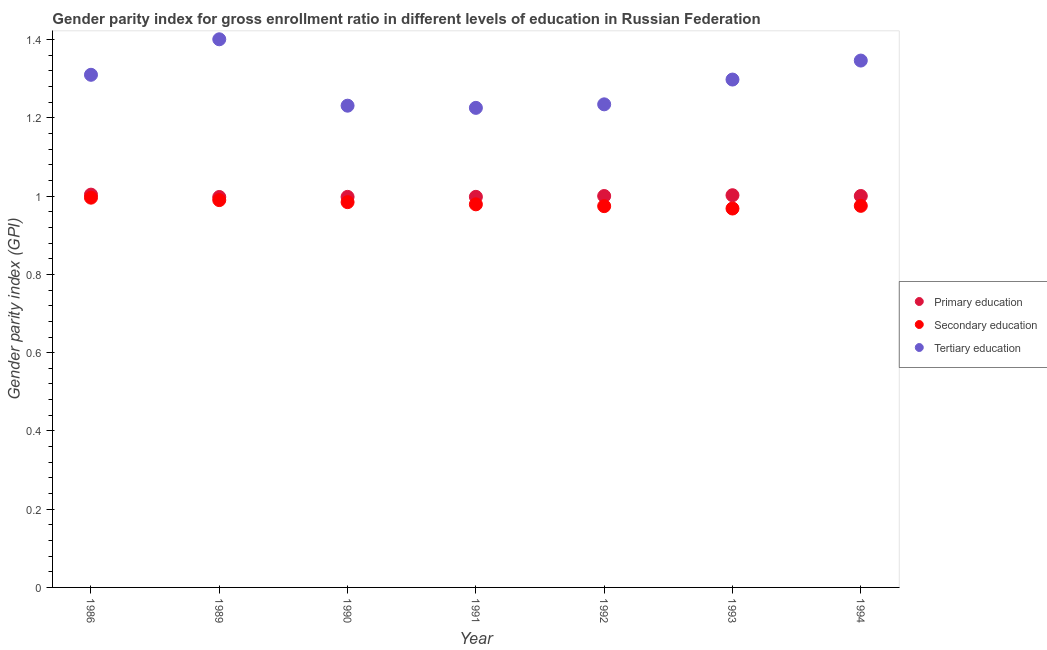Is the number of dotlines equal to the number of legend labels?
Provide a short and direct response. Yes. What is the gender parity index in secondary education in 1989?
Provide a short and direct response. 0.99. Across all years, what is the maximum gender parity index in tertiary education?
Give a very brief answer. 1.4. Across all years, what is the minimum gender parity index in tertiary education?
Ensure brevity in your answer.  1.23. In which year was the gender parity index in secondary education maximum?
Keep it short and to the point. 1986. In which year was the gender parity index in tertiary education minimum?
Your answer should be compact. 1991. What is the total gender parity index in secondary education in the graph?
Keep it short and to the point. 6.87. What is the difference between the gender parity index in tertiary education in 1989 and that in 1994?
Give a very brief answer. 0.05. What is the difference between the gender parity index in primary education in 1994 and the gender parity index in tertiary education in 1986?
Your answer should be compact. -0.31. What is the average gender parity index in tertiary education per year?
Keep it short and to the point. 1.29. In the year 1986, what is the difference between the gender parity index in primary education and gender parity index in secondary education?
Make the answer very short. 0.01. What is the ratio of the gender parity index in tertiary education in 1990 to that in 1993?
Make the answer very short. 0.95. Is the gender parity index in secondary education in 1986 less than that in 1989?
Offer a very short reply. No. What is the difference between the highest and the second highest gender parity index in secondary education?
Provide a short and direct response. 0.01. What is the difference between the highest and the lowest gender parity index in secondary education?
Provide a succinct answer. 0.03. Is it the case that in every year, the sum of the gender parity index in primary education and gender parity index in secondary education is greater than the gender parity index in tertiary education?
Give a very brief answer. Yes. Does the gender parity index in primary education monotonically increase over the years?
Keep it short and to the point. No. How many dotlines are there?
Offer a very short reply. 3. How many years are there in the graph?
Give a very brief answer. 7. Are the values on the major ticks of Y-axis written in scientific E-notation?
Your answer should be compact. No. Where does the legend appear in the graph?
Your answer should be very brief. Center right. How are the legend labels stacked?
Keep it short and to the point. Vertical. What is the title of the graph?
Give a very brief answer. Gender parity index for gross enrollment ratio in different levels of education in Russian Federation. What is the label or title of the Y-axis?
Provide a succinct answer. Gender parity index (GPI). What is the Gender parity index (GPI) in Primary education in 1986?
Your response must be concise. 1. What is the Gender parity index (GPI) in Secondary education in 1986?
Your answer should be very brief. 1. What is the Gender parity index (GPI) in Tertiary education in 1986?
Give a very brief answer. 1.31. What is the Gender parity index (GPI) of Primary education in 1989?
Ensure brevity in your answer.  1. What is the Gender parity index (GPI) in Secondary education in 1989?
Give a very brief answer. 0.99. What is the Gender parity index (GPI) in Tertiary education in 1989?
Provide a short and direct response. 1.4. What is the Gender parity index (GPI) of Primary education in 1990?
Your answer should be very brief. 1. What is the Gender parity index (GPI) of Secondary education in 1990?
Offer a very short reply. 0.98. What is the Gender parity index (GPI) of Tertiary education in 1990?
Keep it short and to the point. 1.23. What is the Gender parity index (GPI) of Primary education in 1991?
Give a very brief answer. 1. What is the Gender parity index (GPI) of Secondary education in 1991?
Your response must be concise. 0.98. What is the Gender parity index (GPI) in Tertiary education in 1991?
Ensure brevity in your answer.  1.23. What is the Gender parity index (GPI) in Primary education in 1992?
Ensure brevity in your answer.  1. What is the Gender parity index (GPI) of Secondary education in 1992?
Your answer should be compact. 0.97. What is the Gender parity index (GPI) of Tertiary education in 1992?
Your response must be concise. 1.23. What is the Gender parity index (GPI) in Primary education in 1993?
Give a very brief answer. 1. What is the Gender parity index (GPI) in Secondary education in 1993?
Provide a short and direct response. 0.97. What is the Gender parity index (GPI) of Tertiary education in 1993?
Provide a succinct answer. 1.3. What is the Gender parity index (GPI) of Primary education in 1994?
Give a very brief answer. 1. What is the Gender parity index (GPI) in Secondary education in 1994?
Offer a very short reply. 0.98. What is the Gender parity index (GPI) of Tertiary education in 1994?
Provide a short and direct response. 1.35. Across all years, what is the maximum Gender parity index (GPI) in Primary education?
Keep it short and to the point. 1. Across all years, what is the maximum Gender parity index (GPI) of Secondary education?
Ensure brevity in your answer.  1. Across all years, what is the maximum Gender parity index (GPI) of Tertiary education?
Keep it short and to the point. 1.4. Across all years, what is the minimum Gender parity index (GPI) in Primary education?
Make the answer very short. 1. Across all years, what is the minimum Gender parity index (GPI) in Secondary education?
Ensure brevity in your answer.  0.97. Across all years, what is the minimum Gender parity index (GPI) of Tertiary education?
Offer a very short reply. 1.23. What is the total Gender parity index (GPI) in Primary education in the graph?
Offer a very short reply. 7. What is the total Gender parity index (GPI) in Secondary education in the graph?
Your answer should be compact. 6.87. What is the total Gender parity index (GPI) of Tertiary education in the graph?
Give a very brief answer. 9.05. What is the difference between the Gender parity index (GPI) in Primary education in 1986 and that in 1989?
Ensure brevity in your answer.  0.01. What is the difference between the Gender parity index (GPI) of Secondary education in 1986 and that in 1989?
Your response must be concise. 0.01. What is the difference between the Gender parity index (GPI) of Tertiary education in 1986 and that in 1989?
Provide a short and direct response. -0.09. What is the difference between the Gender parity index (GPI) of Primary education in 1986 and that in 1990?
Offer a terse response. 0.01. What is the difference between the Gender parity index (GPI) of Secondary education in 1986 and that in 1990?
Your answer should be compact. 0.01. What is the difference between the Gender parity index (GPI) in Tertiary education in 1986 and that in 1990?
Provide a succinct answer. 0.08. What is the difference between the Gender parity index (GPI) in Primary education in 1986 and that in 1991?
Ensure brevity in your answer.  0.01. What is the difference between the Gender parity index (GPI) in Secondary education in 1986 and that in 1991?
Your answer should be very brief. 0.02. What is the difference between the Gender parity index (GPI) in Tertiary education in 1986 and that in 1991?
Give a very brief answer. 0.08. What is the difference between the Gender parity index (GPI) of Primary education in 1986 and that in 1992?
Offer a terse response. 0. What is the difference between the Gender parity index (GPI) of Secondary education in 1986 and that in 1992?
Make the answer very short. 0.02. What is the difference between the Gender parity index (GPI) in Tertiary education in 1986 and that in 1992?
Give a very brief answer. 0.08. What is the difference between the Gender parity index (GPI) of Primary education in 1986 and that in 1993?
Make the answer very short. 0. What is the difference between the Gender parity index (GPI) of Secondary education in 1986 and that in 1993?
Provide a short and direct response. 0.03. What is the difference between the Gender parity index (GPI) in Tertiary education in 1986 and that in 1993?
Give a very brief answer. 0.01. What is the difference between the Gender parity index (GPI) in Primary education in 1986 and that in 1994?
Offer a terse response. 0. What is the difference between the Gender parity index (GPI) in Secondary education in 1986 and that in 1994?
Keep it short and to the point. 0.02. What is the difference between the Gender parity index (GPI) in Tertiary education in 1986 and that in 1994?
Your response must be concise. -0.04. What is the difference between the Gender parity index (GPI) in Primary education in 1989 and that in 1990?
Offer a terse response. -0. What is the difference between the Gender parity index (GPI) in Secondary education in 1989 and that in 1990?
Make the answer very short. 0.01. What is the difference between the Gender parity index (GPI) in Tertiary education in 1989 and that in 1990?
Provide a short and direct response. 0.17. What is the difference between the Gender parity index (GPI) in Primary education in 1989 and that in 1991?
Provide a short and direct response. -0. What is the difference between the Gender parity index (GPI) in Secondary education in 1989 and that in 1991?
Provide a succinct answer. 0.01. What is the difference between the Gender parity index (GPI) of Tertiary education in 1989 and that in 1991?
Your answer should be very brief. 0.18. What is the difference between the Gender parity index (GPI) in Primary education in 1989 and that in 1992?
Provide a succinct answer. -0. What is the difference between the Gender parity index (GPI) of Secondary education in 1989 and that in 1992?
Make the answer very short. 0.02. What is the difference between the Gender parity index (GPI) in Tertiary education in 1989 and that in 1992?
Provide a short and direct response. 0.17. What is the difference between the Gender parity index (GPI) in Primary education in 1989 and that in 1993?
Offer a very short reply. -0. What is the difference between the Gender parity index (GPI) of Secondary education in 1989 and that in 1993?
Your answer should be very brief. 0.02. What is the difference between the Gender parity index (GPI) of Tertiary education in 1989 and that in 1993?
Provide a succinct answer. 0.1. What is the difference between the Gender parity index (GPI) of Primary education in 1989 and that in 1994?
Offer a terse response. -0. What is the difference between the Gender parity index (GPI) in Secondary education in 1989 and that in 1994?
Ensure brevity in your answer.  0.01. What is the difference between the Gender parity index (GPI) in Tertiary education in 1989 and that in 1994?
Offer a very short reply. 0.05. What is the difference between the Gender parity index (GPI) of Primary education in 1990 and that in 1991?
Your answer should be very brief. -0. What is the difference between the Gender parity index (GPI) in Secondary education in 1990 and that in 1991?
Keep it short and to the point. 0.01. What is the difference between the Gender parity index (GPI) of Tertiary education in 1990 and that in 1991?
Your response must be concise. 0.01. What is the difference between the Gender parity index (GPI) in Primary education in 1990 and that in 1992?
Give a very brief answer. -0. What is the difference between the Gender parity index (GPI) in Secondary education in 1990 and that in 1992?
Offer a very short reply. 0.01. What is the difference between the Gender parity index (GPI) in Tertiary education in 1990 and that in 1992?
Offer a terse response. -0. What is the difference between the Gender parity index (GPI) of Primary education in 1990 and that in 1993?
Keep it short and to the point. -0. What is the difference between the Gender parity index (GPI) of Secondary education in 1990 and that in 1993?
Your answer should be compact. 0.02. What is the difference between the Gender parity index (GPI) in Tertiary education in 1990 and that in 1993?
Give a very brief answer. -0.07. What is the difference between the Gender parity index (GPI) of Primary education in 1990 and that in 1994?
Keep it short and to the point. -0. What is the difference between the Gender parity index (GPI) in Secondary education in 1990 and that in 1994?
Offer a terse response. 0.01. What is the difference between the Gender parity index (GPI) of Tertiary education in 1990 and that in 1994?
Give a very brief answer. -0.12. What is the difference between the Gender parity index (GPI) of Primary education in 1991 and that in 1992?
Your answer should be compact. -0. What is the difference between the Gender parity index (GPI) in Secondary education in 1991 and that in 1992?
Your response must be concise. 0. What is the difference between the Gender parity index (GPI) in Tertiary education in 1991 and that in 1992?
Ensure brevity in your answer.  -0.01. What is the difference between the Gender parity index (GPI) of Primary education in 1991 and that in 1993?
Give a very brief answer. -0. What is the difference between the Gender parity index (GPI) in Secondary education in 1991 and that in 1993?
Give a very brief answer. 0.01. What is the difference between the Gender parity index (GPI) in Tertiary education in 1991 and that in 1993?
Offer a terse response. -0.07. What is the difference between the Gender parity index (GPI) in Primary education in 1991 and that in 1994?
Provide a short and direct response. -0. What is the difference between the Gender parity index (GPI) of Secondary education in 1991 and that in 1994?
Keep it short and to the point. 0. What is the difference between the Gender parity index (GPI) of Tertiary education in 1991 and that in 1994?
Offer a very short reply. -0.12. What is the difference between the Gender parity index (GPI) in Primary education in 1992 and that in 1993?
Provide a short and direct response. -0. What is the difference between the Gender parity index (GPI) in Secondary education in 1992 and that in 1993?
Provide a short and direct response. 0.01. What is the difference between the Gender parity index (GPI) of Tertiary education in 1992 and that in 1993?
Your answer should be compact. -0.06. What is the difference between the Gender parity index (GPI) of Primary education in 1992 and that in 1994?
Give a very brief answer. -0. What is the difference between the Gender parity index (GPI) in Secondary education in 1992 and that in 1994?
Your response must be concise. -0. What is the difference between the Gender parity index (GPI) in Tertiary education in 1992 and that in 1994?
Offer a very short reply. -0.11. What is the difference between the Gender parity index (GPI) of Primary education in 1993 and that in 1994?
Ensure brevity in your answer.  0. What is the difference between the Gender parity index (GPI) in Secondary education in 1993 and that in 1994?
Your answer should be compact. -0.01. What is the difference between the Gender parity index (GPI) of Tertiary education in 1993 and that in 1994?
Offer a terse response. -0.05. What is the difference between the Gender parity index (GPI) of Primary education in 1986 and the Gender parity index (GPI) of Secondary education in 1989?
Provide a succinct answer. 0.01. What is the difference between the Gender parity index (GPI) in Primary education in 1986 and the Gender parity index (GPI) in Tertiary education in 1989?
Offer a terse response. -0.4. What is the difference between the Gender parity index (GPI) in Secondary education in 1986 and the Gender parity index (GPI) in Tertiary education in 1989?
Offer a terse response. -0.4. What is the difference between the Gender parity index (GPI) in Primary education in 1986 and the Gender parity index (GPI) in Secondary education in 1990?
Your response must be concise. 0.02. What is the difference between the Gender parity index (GPI) of Primary education in 1986 and the Gender parity index (GPI) of Tertiary education in 1990?
Offer a terse response. -0.23. What is the difference between the Gender parity index (GPI) of Secondary education in 1986 and the Gender parity index (GPI) of Tertiary education in 1990?
Provide a succinct answer. -0.24. What is the difference between the Gender parity index (GPI) in Primary education in 1986 and the Gender parity index (GPI) in Secondary education in 1991?
Your answer should be compact. 0.02. What is the difference between the Gender parity index (GPI) in Primary education in 1986 and the Gender parity index (GPI) in Tertiary education in 1991?
Ensure brevity in your answer.  -0.22. What is the difference between the Gender parity index (GPI) in Secondary education in 1986 and the Gender parity index (GPI) in Tertiary education in 1991?
Your answer should be compact. -0.23. What is the difference between the Gender parity index (GPI) of Primary education in 1986 and the Gender parity index (GPI) of Secondary education in 1992?
Ensure brevity in your answer.  0.03. What is the difference between the Gender parity index (GPI) of Primary education in 1986 and the Gender parity index (GPI) of Tertiary education in 1992?
Make the answer very short. -0.23. What is the difference between the Gender parity index (GPI) of Secondary education in 1986 and the Gender parity index (GPI) of Tertiary education in 1992?
Your answer should be very brief. -0.24. What is the difference between the Gender parity index (GPI) in Primary education in 1986 and the Gender parity index (GPI) in Secondary education in 1993?
Provide a short and direct response. 0.04. What is the difference between the Gender parity index (GPI) of Primary education in 1986 and the Gender parity index (GPI) of Tertiary education in 1993?
Provide a short and direct response. -0.29. What is the difference between the Gender parity index (GPI) in Secondary education in 1986 and the Gender parity index (GPI) in Tertiary education in 1993?
Keep it short and to the point. -0.3. What is the difference between the Gender parity index (GPI) in Primary education in 1986 and the Gender parity index (GPI) in Secondary education in 1994?
Your answer should be compact. 0.03. What is the difference between the Gender parity index (GPI) in Primary education in 1986 and the Gender parity index (GPI) in Tertiary education in 1994?
Keep it short and to the point. -0.34. What is the difference between the Gender parity index (GPI) of Secondary education in 1986 and the Gender parity index (GPI) of Tertiary education in 1994?
Your response must be concise. -0.35. What is the difference between the Gender parity index (GPI) of Primary education in 1989 and the Gender parity index (GPI) of Secondary education in 1990?
Offer a terse response. 0.01. What is the difference between the Gender parity index (GPI) of Primary education in 1989 and the Gender parity index (GPI) of Tertiary education in 1990?
Provide a short and direct response. -0.23. What is the difference between the Gender parity index (GPI) in Secondary education in 1989 and the Gender parity index (GPI) in Tertiary education in 1990?
Ensure brevity in your answer.  -0.24. What is the difference between the Gender parity index (GPI) of Primary education in 1989 and the Gender parity index (GPI) of Secondary education in 1991?
Ensure brevity in your answer.  0.02. What is the difference between the Gender parity index (GPI) of Primary education in 1989 and the Gender parity index (GPI) of Tertiary education in 1991?
Provide a succinct answer. -0.23. What is the difference between the Gender parity index (GPI) of Secondary education in 1989 and the Gender parity index (GPI) of Tertiary education in 1991?
Keep it short and to the point. -0.24. What is the difference between the Gender parity index (GPI) of Primary education in 1989 and the Gender parity index (GPI) of Secondary education in 1992?
Your response must be concise. 0.02. What is the difference between the Gender parity index (GPI) in Primary education in 1989 and the Gender parity index (GPI) in Tertiary education in 1992?
Keep it short and to the point. -0.24. What is the difference between the Gender parity index (GPI) of Secondary education in 1989 and the Gender parity index (GPI) of Tertiary education in 1992?
Offer a terse response. -0.24. What is the difference between the Gender parity index (GPI) of Primary education in 1989 and the Gender parity index (GPI) of Secondary education in 1993?
Keep it short and to the point. 0.03. What is the difference between the Gender parity index (GPI) of Primary education in 1989 and the Gender parity index (GPI) of Tertiary education in 1993?
Make the answer very short. -0.3. What is the difference between the Gender parity index (GPI) in Secondary education in 1989 and the Gender parity index (GPI) in Tertiary education in 1993?
Your answer should be compact. -0.31. What is the difference between the Gender parity index (GPI) of Primary education in 1989 and the Gender parity index (GPI) of Secondary education in 1994?
Your response must be concise. 0.02. What is the difference between the Gender parity index (GPI) of Primary education in 1989 and the Gender parity index (GPI) of Tertiary education in 1994?
Keep it short and to the point. -0.35. What is the difference between the Gender parity index (GPI) of Secondary education in 1989 and the Gender parity index (GPI) of Tertiary education in 1994?
Your response must be concise. -0.36. What is the difference between the Gender parity index (GPI) in Primary education in 1990 and the Gender parity index (GPI) in Secondary education in 1991?
Provide a short and direct response. 0.02. What is the difference between the Gender parity index (GPI) in Primary education in 1990 and the Gender parity index (GPI) in Tertiary education in 1991?
Ensure brevity in your answer.  -0.23. What is the difference between the Gender parity index (GPI) of Secondary education in 1990 and the Gender parity index (GPI) of Tertiary education in 1991?
Provide a succinct answer. -0.24. What is the difference between the Gender parity index (GPI) of Primary education in 1990 and the Gender parity index (GPI) of Secondary education in 1992?
Ensure brevity in your answer.  0.02. What is the difference between the Gender parity index (GPI) in Primary education in 1990 and the Gender parity index (GPI) in Tertiary education in 1992?
Provide a short and direct response. -0.24. What is the difference between the Gender parity index (GPI) of Primary education in 1990 and the Gender parity index (GPI) of Secondary education in 1993?
Keep it short and to the point. 0.03. What is the difference between the Gender parity index (GPI) of Primary education in 1990 and the Gender parity index (GPI) of Tertiary education in 1993?
Provide a short and direct response. -0.3. What is the difference between the Gender parity index (GPI) in Secondary education in 1990 and the Gender parity index (GPI) in Tertiary education in 1993?
Your response must be concise. -0.31. What is the difference between the Gender parity index (GPI) in Primary education in 1990 and the Gender parity index (GPI) in Secondary education in 1994?
Your response must be concise. 0.02. What is the difference between the Gender parity index (GPI) of Primary education in 1990 and the Gender parity index (GPI) of Tertiary education in 1994?
Your answer should be compact. -0.35. What is the difference between the Gender parity index (GPI) of Secondary education in 1990 and the Gender parity index (GPI) of Tertiary education in 1994?
Give a very brief answer. -0.36. What is the difference between the Gender parity index (GPI) in Primary education in 1991 and the Gender parity index (GPI) in Secondary education in 1992?
Ensure brevity in your answer.  0.02. What is the difference between the Gender parity index (GPI) in Primary education in 1991 and the Gender parity index (GPI) in Tertiary education in 1992?
Make the answer very short. -0.24. What is the difference between the Gender parity index (GPI) in Secondary education in 1991 and the Gender parity index (GPI) in Tertiary education in 1992?
Give a very brief answer. -0.26. What is the difference between the Gender parity index (GPI) of Primary education in 1991 and the Gender parity index (GPI) of Secondary education in 1993?
Give a very brief answer. 0.03. What is the difference between the Gender parity index (GPI) in Primary education in 1991 and the Gender parity index (GPI) in Tertiary education in 1993?
Provide a succinct answer. -0.3. What is the difference between the Gender parity index (GPI) in Secondary education in 1991 and the Gender parity index (GPI) in Tertiary education in 1993?
Offer a very short reply. -0.32. What is the difference between the Gender parity index (GPI) in Primary education in 1991 and the Gender parity index (GPI) in Secondary education in 1994?
Offer a very short reply. 0.02. What is the difference between the Gender parity index (GPI) of Primary education in 1991 and the Gender parity index (GPI) of Tertiary education in 1994?
Make the answer very short. -0.35. What is the difference between the Gender parity index (GPI) of Secondary education in 1991 and the Gender parity index (GPI) of Tertiary education in 1994?
Offer a very short reply. -0.37. What is the difference between the Gender parity index (GPI) of Primary education in 1992 and the Gender parity index (GPI) of Secondary education in 1993?
Give a very brief answer. 0.03. What is the difference between the Gender parity index (GPI) of Primary education in 1992 and the Gender parity index (GPI) of Tertiary education in 1993?
Make the answer very short. -0.3. What is the difference between the Gender parity index (GPI) in Secondary education in 1992 and the Gender parity index (GPI) in Tertiary education in 1993?
Offer a very short reply. -0.32. What is the difference between the Gender parity index (GPI) in Primary education in 1992 and the Gender parity index (GPI) in Secondary education in 1994?
Your answer should be very brief. 0.03. What is the difference between the Gender parity index (GPI) in Primary education in 1992 and the Gender parity index (GPI) in Tertiary education in 1994?
Offer a very short reply. -0.35. What is the difference between the Gender parity index (GPI) in Secondary education in 1992 and the Gender parity index (GPI) in Tertiary education in 1994?
Your response must be concise. -0.37. What is the difference between the Gender parity index (GPI) in Primary education in 1993 and the Gender parity index (GPI) in Secondary education in 1994?
Provide a short and direct response. 0.03. What is the difference between the Gender parity index (GPI) in Primary education in 1993 and the Gender parity index (GPI) in Tertiary education in 1994?
Your answer should be compact. -0.34. What is the difference between the Gender parity index (GPI) in Secondary education in 1993 and the Gender parity index (GPI) in Tertiary education in 1994?
Your answer should be very brief. -0.38. What is the average Gender parity index (GPI) in Primary education per year?
Your response must be concise. 1. What is the average Gender parity index (GPI) in Secondary education per year?
Your answer should be very brief. 0.98. What is the average Gender parity index (GPI) in Tertiary education per year?
Offer a very short reply. 1.29. In the year 1986, what is the difference between the Gender parity index (GPI) in Primary education and Gender parity index (GPI) in Secondary education?
Give a very brief answer. 0.01. In the year 1986, what is the difference between the Gender parity index (GPI) of Primary education and Gender parity index (GPI) of Tertiary education?
Your response must be concise. -0.31. In the year 1986, what is the difference between the Gender parity index (GPI) of Secondary education and Gender parity index (GPI) of Tertiary education?
Ensure brevity in your answer.  -0.31. In the year 1989, what is the difference between the Gender parity index (GPI) of Primary education and Gender parity index (GPI) of Secondary education?
Keep it short and to the point. 0.01. In the year 1989, what is the difference between the Gender parity index (GPI) in Primary education and Gender parity index (GPI) in Tertiary education?
Keep it short and to the point. -0.4. In the year 1989, what is the difference between the Gender parity index (GPI) of Secondary education and Gender parity index (GPI) of Tertiary education?
Provide a short and direct response. -0.41. In the year 1990, what is the difference between the Gender parity index (GPI) of Primary education and Gender parity index (GPI) of Secondary education?
Provide a succinct answer. 0.01. In the year 1990, what is the difference between the Gender parity index (GPI) of Primary education and Gender parity index (GPI) of Tertiary education?
Provide a short and direct response. -0.23. In the year 1990, what is the difference between the Gender parity index (GPI) of Secondary education and Gender parity index (GPI) of Tertiary education?
Your answer should be very brief. -0.25. In the year 1991, what is the difference between the Gender parity index (GPI) of Primary education and Gender parity index (GPI) of Secondary education?
Your answer should be compact. 0.02. In the year 1991, what is the difference between the Gender parity index (GPI) in Primary education and Gender parity index (GPI) in Tertiary education?
Offer a very short reply. -0.23. In the year 1991, what is the difference between the Gender parity index (GPI) in Secondary education and Gender parity index (GPI) in Tertiary education?
Offer a terse response. -0.25. In the year 1992, what is the difference between the Gender parity index (GPI) in Primary education and Gender parity index (GPI) in Secondary education?
Ensure brevity in your answer.  0.03. In the year 1992, what is the difference between the Gender parity index (GPI) of Primary education and Gender parity index (GPI) of Tertiary education?
Your answer should be very brief. -0.23. In the year 1992, what is the difference between the Gender parity index (GPI) in Secondary education and Gender parity index (GPI) in Tertiary education?
Offer a terse response. -0.26. In the year 1993, what is the difference between the Gender parity index (GPI) of Primary education and Gender parity index (GPI) of Secondary education?
Offer a terse response. 0.03. In the year 1993, what is the difference between the Gender parity index (GPI) of Primary education and Gender parity index (GPI) of Tertiary education?
Keep it short and to the point. -0.3. In the year 1993, what is the difference between the Gender parity index (GPI) in Secondary education and Gender parity index (GPI) in Tertiary education?
Provide a succinct answer. -0.33. In the year 1994, what is the difference between the Gender parity index (GPI) in Primary education and Gender parity index (GPI) in Secondary education?
Your answer should be very brief. 0.03. In the year 1994, what is the difference between the Gender parity index (GPI) of Primary education and Gender parity index (GPI) of Tertiary education?
Your answer should be compact. -0.35. In the year 1994, what is the difference between the Gender parity index (GPI) of Secondary education and Gender parity index (GPI) of Tertiary education?
Offer a very short reply. -0.37. What is the ratio of the Gender parity index (GPI) of Primary education in 1986 to that in 1989?
Offer a very short reply. 1.01. What is the ratio of the Gender parity index (GPI) of Secondary education in 1986 to that in 1989?
Offer a very short reply. 1.01. What is the ratio of the Gender parity index (GPI) in Tertiary education in 1986 to that in 1989?
Provide a succinct answer. 0.94. What is the ratio of the Gender parity index (GPI) of Secondary education in 1986 to that in 1990?
Ensure brevity in your answer.  1.01. What is the ratio of the Gender parity index (GPI) of Tertiary education in 1986 to that in 1990?
Provide a succinct answer. 1.06. What is the ratio of the Gender parity index (GPI) in Primary education in 1986 to that in 1991?
Offer a terse response. 1.01. What is the ratio of the Gender parity index (GPI) in Secondary education in 1986 to that in 1991?
Make the answer very short. 1.02. What is the ratio of the Gender parity index (GPI) in Tertiary education in 1986 to that in 1991?
Give a very brief answer. 1.07. What is the ratio of the Gender parity index (GPI) of Secondary education in 1986 to that in 1992?
Keep it short and to the point. 1.02. What is the ratio of the Gender parity index (GPI) in Tertiary education in 1986 to that in 1992?
Give a very brief answer. 1.06. What is the ratio of the Gender parity index (GPI) of Secondary education in 1986 to that in 1993?
Your answer should be very brief. 1.03. What is the ratio of the Gender parity index (GPI) in Tertiary education in 1986 to that in 1993?
Offer a very short reply. 1.01. What is the ratio of the Gender parity index (GPI) of Primary education in 1986 to that in 1994?
Make the answer very short. 1. What is the ratio of the Gender parity index (GPI) in Secondary education in 1986 to that in 1994?
Your answer should be compact. 1.02. What is the ratio of the Gender parity index (GPI) in Tertiary education in 1989 to that in 1990?
Keep it short and to the point. 1.14. What is the ratio of the Gender parity index (GPI) in Primary education in 1989 to that in 1991?
Keep it short and to the point. 1. What is the ratio of the Gender parity index (GPI) of Tertiary education in 1989 to that in 1991?
Your answer should be very brief. 1.14. What is the ratio of the Gender parity index (GPI) in Primary education in 1989 to that in 1992?
Keep it short and to the point. 1. What is the ratio of the Gender parity index (GPI) in Secondary education in 1989 to that in 1992?
Ensure brevity in your answer.  1.02. What is the ratio of the Gender parity index (GPI) in Tertiary education in 1989 to that in 1992?
Keep it short and to the point. 1.13. What is the ratio of the Gender parity index (GPI) in Primary education in 1989 to that in 1993?
Keep it short and to the point. 1. What is the ratio of the Gender parity index (GPI) in Secondary education in 1989 to that in 1993?
Your response must be concise. 1.02. What is the ratio of the Gender parity index (GPI) of Tertiary education in 1989 to that in 1993?
Provide a short and direct response. 1.08. What is the ratio of the Gender parity index (GPI) of Primary education in 1989 to that in 1994?
Provide a short and direct response. 1. What is the ratio of the Gender parity index (GPI) of Secondary education in 1989 to that in 1994?
Your answer should be compact. 1.02. What is the ratio of the Gender parity index (GPI) in Tertiary education in 1989 to that in 1994?
Give a very brief answer. 1.04. What is the ratio of the Gender parity index (GPI) of Primary education in 1990 to that in 1992?
Your response must be concise. 1. What is the ratio of the Gender parity index (GPI) of Secondary education in 1990 to that in 1992?
Give a very brief answer. 1.01. What is the ratio of the Gender parity index (GPI) of Primary education in 1990 to that in 1993?
Ensure brevity in your answer.  1. What is the ratio of the Gender parity index (GPI) in Secondary education in 1990 to that in 1993?
Ensure brevity in your answer.  1.02. What is the ratio of the Gender parity index (GPI) of Tertiary education in 1990 to that in 1993?
Your response must be concise. 0.95. What is the ratio of the Gender parity index (GPI) of Secondary education in 1990 to that in 1994?
Keep it short and to the point. 1.01. What is the ratio of the Gender parity index (GPI) in Tertiary education in 1990 to that in 1994?
Give a very brief answer. 0.91. What is the ratio of the Gender parity index (GPI) of Secondary education in 1991 to that in 1993?
Provide a succinct answer. 1.01. What is the ratio of the Gender parity index (GPI) of Tertiary education in 1991 to that in 1993?
Make the answer very short. 0.94. What is the ratio of the Gender parity index (GPI) in Primary education in 1991 to that in 1994?
Offer a terse response. 1. What is the ratio of the Gender parity index (GPI) in Secondary education in 1991 to that in 1994?
Your answer should be compact. 1. What is the ratio of the Gender parity index (GPI) of Tertiary education in 1991 to that in 1994?
Offer a very short reply. 0.91. What is the ratio of the Gender parity index (GPI) in Tertiary education in 1992 to that in 1993?
Offer a terse response. 0.95. What is the ratio of the Gender parity index (GPI) of Primary education in 1992 to that in 1994?
Give a very brief answer. 1. What is the ratio of the Gender parity index (GPI) of Secondary education in 1992 to that in 1994?
Ensure brevity in your answer.  1. What is the ratio of the Gender parity index (GPI) in Tertiary education in 1992 to that in 1994?
Provide a short and direct response. 0.92. What is the difference between the highest and the second highest Gender parity index (GPI) in Primary education?
Your answer should be very brief. 0. What is the difference between the highest and the second highest Gender parity index (GPI) in Secondary education?
Give a very brief answer. 0.01. What is the difference between the highest and the second highest Gender parity index (GPI) in Tertiary education?
Your answer should be very brief. 0.05. What is the difference between the highest and the lowest Gender parity index (GPI) in Primary education?
Provide a succinct answer. 0.01. What is the difference between the highest and the lowest Gender parity index (GPI) of Secondary education?
Give a very brief answer. 0.03. What is the difference between the highest and the lowest Gender parity index (GPI) in Tertiary education?
Your answer should be very brief. 0.18. 